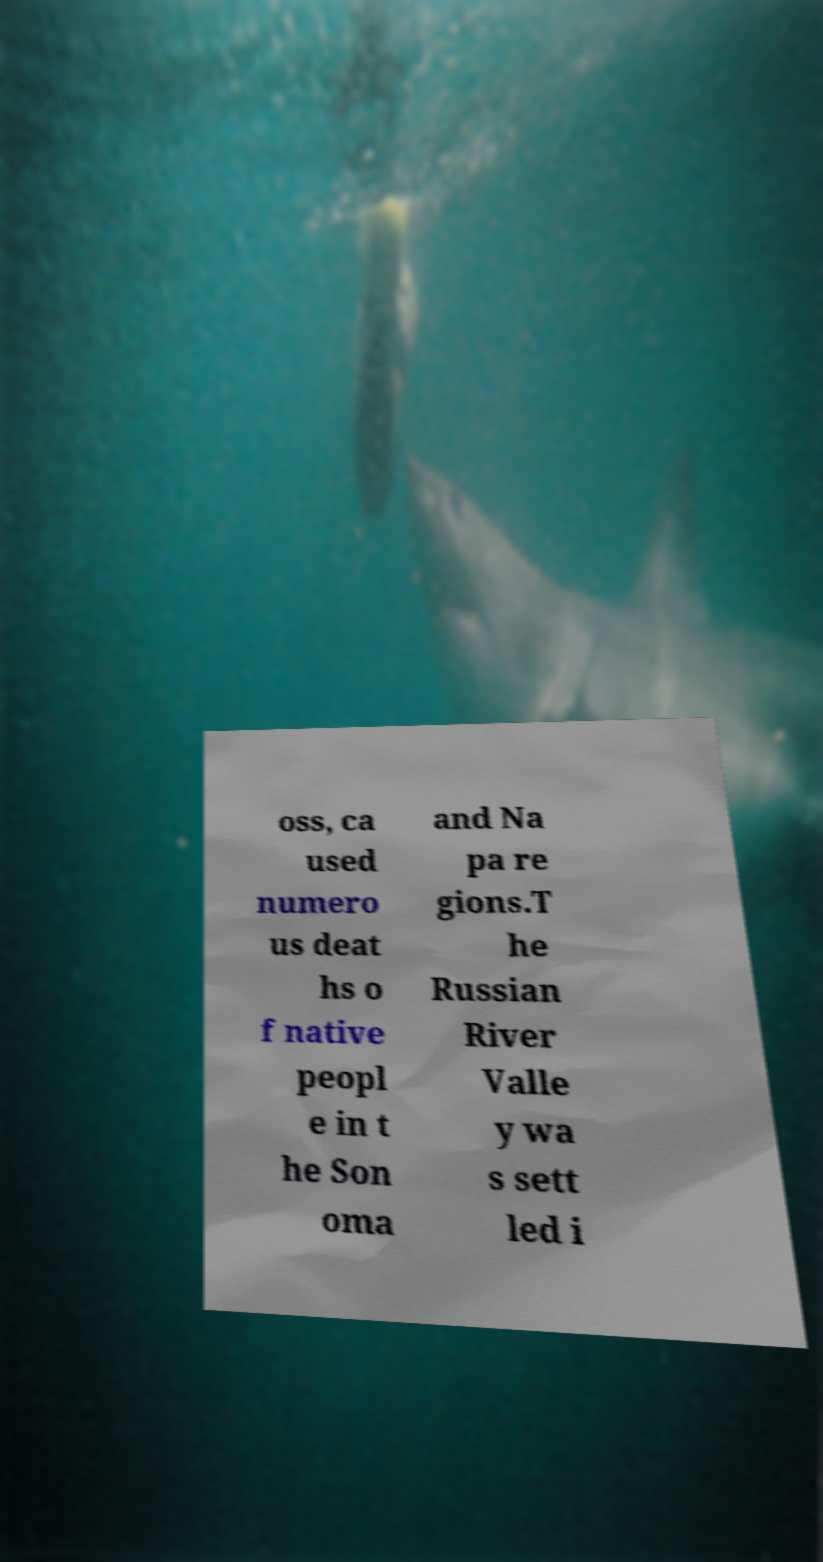Please read and relay the text visible in this image. What does it say? oss, ca used numero us deat hs o f native peopl e in t he Son oma and Na pa re gions.T he Russian River Valle y wa s sett led i 